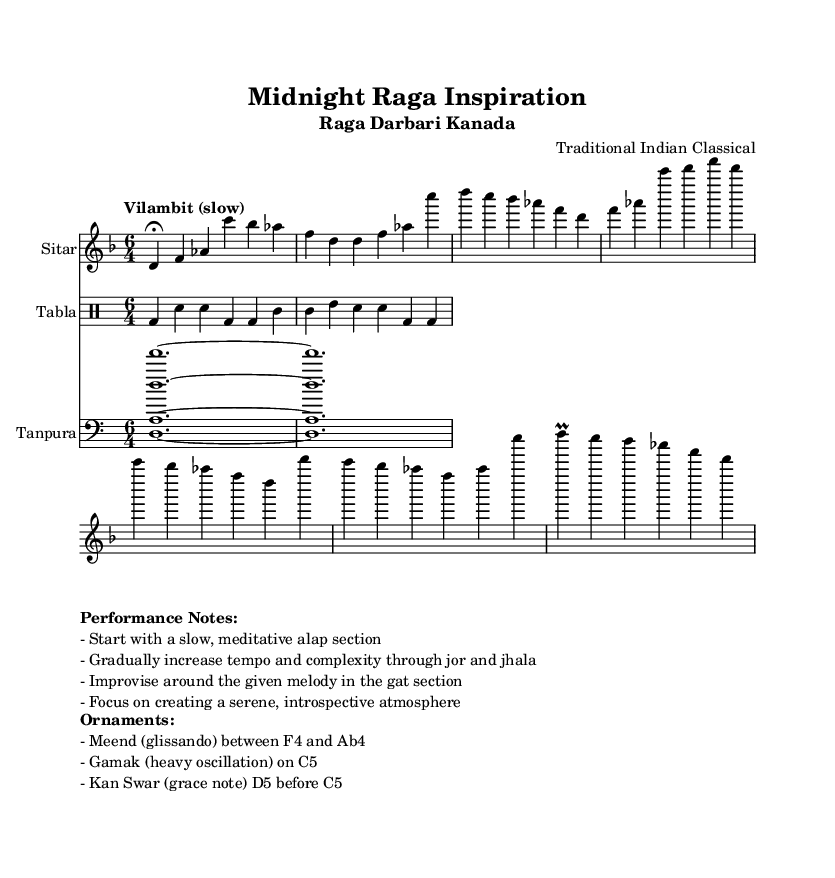What is the key signature of this music? The key signature is indicated by the key signature symbol at the beginning of the staff, showing one flat (B) which corresponds to the D minor scale.
Answer: D minor What is the time signature of the piece? The time signature is shown at the beginning of the score, represented by the numbers 6 and 4, which indicates six beats per measure with a quarter note getting one beat.
Answer: 6/4 What tempo marking is indicated in the sheet music? The tempo marking is shown above the staff, stating "Vilambit (slow)," which signifies the pace at which the music is to be played, implying a slow tempo.
Answer: Vilambit What are the three sections of the performance structure? The performance structure consists of three sections: Alap, Jor, and Jhala, each section is characterized by distinct musical features and progressions, as indicated in the performance notes.
Answer: Alap, Jor, Jhala What ornament is suggested on the note C5? The sheet music suggests the use of "Gamak," a heavy oscillation ornament that adds expressiveness to the note C5, as noted in the ornaments section.
Answer: Gamak How many instruments are represented in this score? By counting the distinct staves in the score, there are three instruments listed: Sitar, Tabla, and Tanpura, each providing a unique role in the ensemble.
Answer: Three What type of mood is created through the performance notes? The performance notes indicate the desired mood as "serene" and "introspective," suggesting that the piece should evoke a peaceful and reflective state while played.
Answer: Serene, introspective 